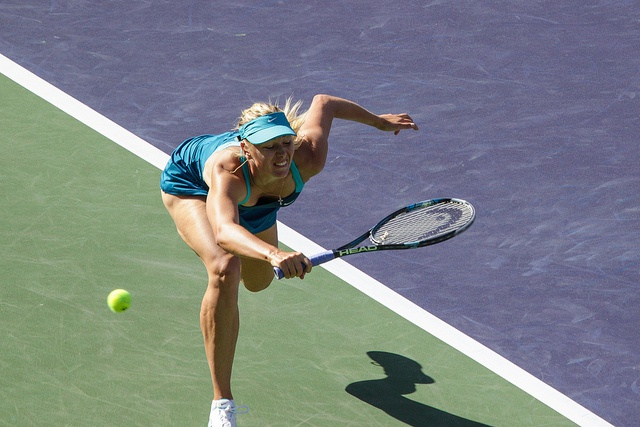Describe the objects in this image and their specific colors. I can see people in gray, maroon, ivory, and black tones, tennis racket in gray, darkgray, and black tones, and sports ball in gray, olive, khaki, and lightyellow tones in this image. 